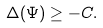Convert formula to latex. <formula><loc_0><loc_0><loc_500><loc_500>\label l { e q \colon c 2 } \Delta ( \Psi ) \geq - C .</formula> 